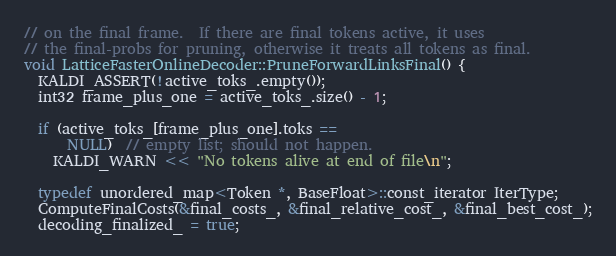Convert code to text. <code><loc_0><loc_0><loc_500><loc_500><_C++_>// on the final frame.  If there are final tokens active, it uses
// the final-probs for pruning, otherwise it treats all tokens as final.
void LatticeFasterOnlineDecoder::PruneForwardLinksFinal() {
  KALDI_ASSERT(!active_toks_.empty());
  int32 frame_plus_one = active_toks_.size() - 1;

  if (active_toks_[frame_plus_one].toks ==
      NULL)  // empty list; should not happen.
    KALDI_WARN << "No tokens alive at end of file\n";

  typedef unordered_map<Token *, BaseFloat>::const_iterator IterType;
  ComputeFinalCosts(&final_costs_, &final_relative_cost_, &final_best_cost_);
  decoding_finalized_ = true;</code> 